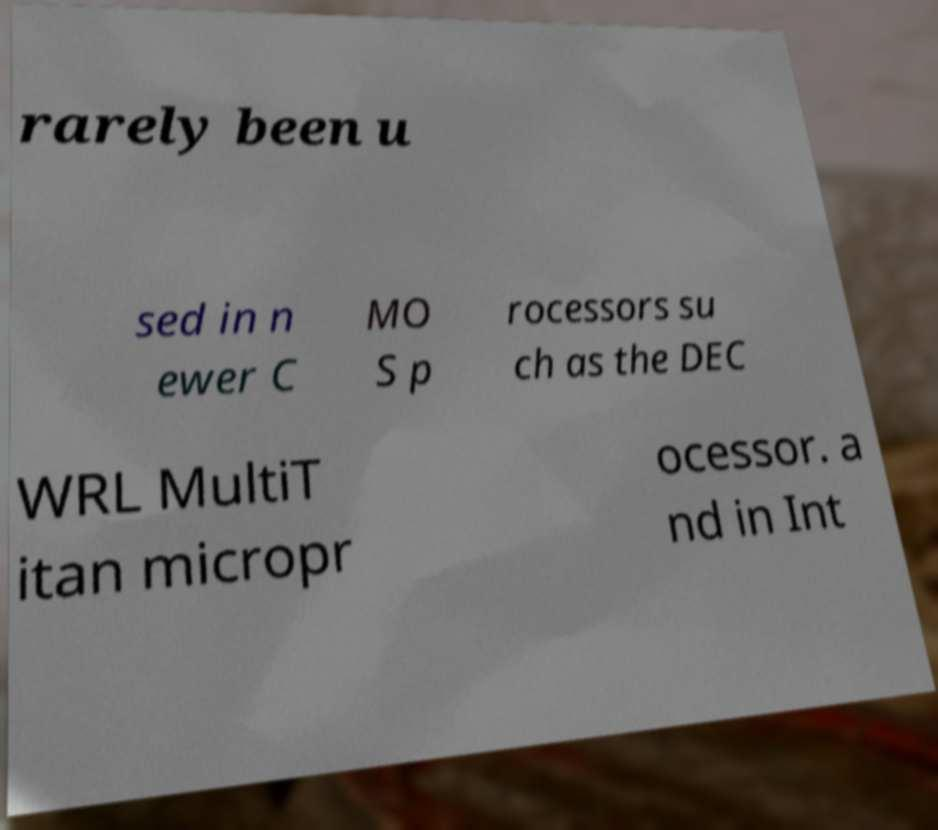Please identify and transcribe the text found in this image. rarely been u sed in n ewer C MO S p rocessors su ch as the DEC WRL MultiT itan micropr ocessor. a nd in Int 